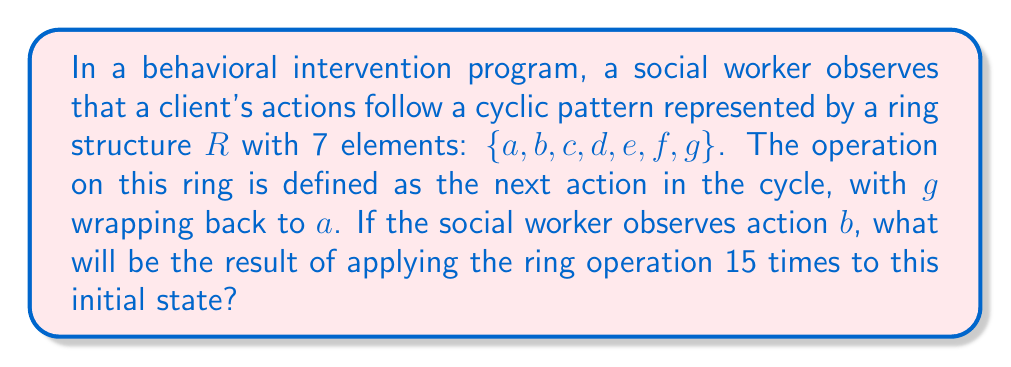Help me with this question. To solve this problem, we need to understand the cyclic nature of the ring structure and how it relates to behavioral patterns. Let's break it down step-by-step:

1) The ring $R$ has 7 elements: $\{a, b, c, d, e, f, g\}$

2) The operation is defined as moving to the next action in the cycle. This means:
   $a \rightarrow b$, $b \rightarrow c$, $c \rightarrow d$, $d \rightarrow e$, $e \rightarrow f$, $f \rightarrow g$, $g \rightarrow a$

3) We start with action $b$, and we need to apply the operation 15 times.

4) To find the result, we can use modular arithmetic. Each complete cycle through the ring takes 7 operations.

5) We can express 15 as: $15 = 2 \times 7 + 1$

6) This means that after 15 operations, we will have completed 2 full cycles (which brings us back to $b$) plus 1 additional step.

7) Starting from $b$, one additional step brings us to $c$.

Therefore, after 15 applications of the ring operation starting from $b$, we will end up at $c$.

This can be expressed mathematically as:

$$b + 15 \equiv c \pmod{7}$$

Where $+$ represents the ring operation and $\equiv$ denotes congruence in modular arithmetic.
Answer: $c$ 